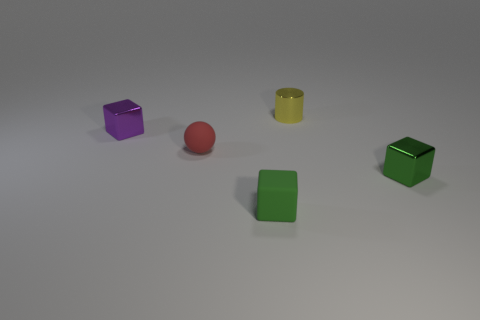There is a tiny object that is behind the small matte block and in front of the red object; what is its material?
Your answer should be very brief. Metal. Is the number of blocks less than the number of metal cubes?
Offer a very short reply. No. There is a green block that is left of the green thing to the right of the yellow shiny cylinder; what size is it?
Your response must be concise. Small. There is a matte object that is behind the matte object in front of the small shiny object that is in front of the purple metal object; what is its shape?
Your answer should be very brief. Sphere. What color is the other small block that is the same material as the small purple cube?
Provide a short and direct response. Green. There is a small shiny block that is right of the small metallic cube that is on the left side of the tiny green block that is right of the yellow shiny cylinder; what is its color?
Your answer should be very brief. Green. What number of cylinders are green metallic things or tiny purple metallic things?
Keep it short and to the point. 0. What is the material of the tiny thing that is the same color as the rubber cube?
Give a very brief answer. Metal. Is the color of the small cylinder the same as the metallic cube behind the sphere?
Your answer should be compact. No. What is the color of the tiny matte cube?
Ensure brevity in your answer.  Green. 